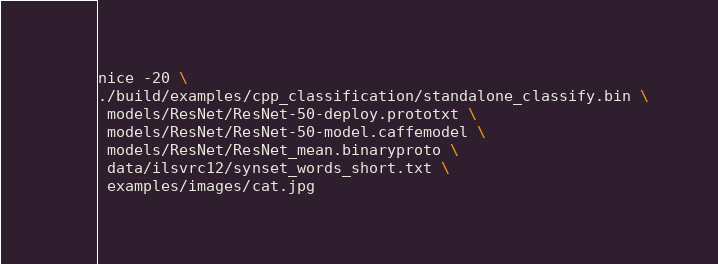<code> <loc_0><loc_0><loc_500><loc_500><_Bash_>nice -20 \
./build/examples/cpp_classification/standalone_classify.bin \
 models/ResNet/ResNet-50-deploy.prototxt \
 models/ResNet/ResNet-50-model.caffemodel \
 models/ResNet/ResNet_mean.binaryproto \
 data/ilsvrc12/synset_words_short.txt \
 examples/images/cat.jpg
</code> 